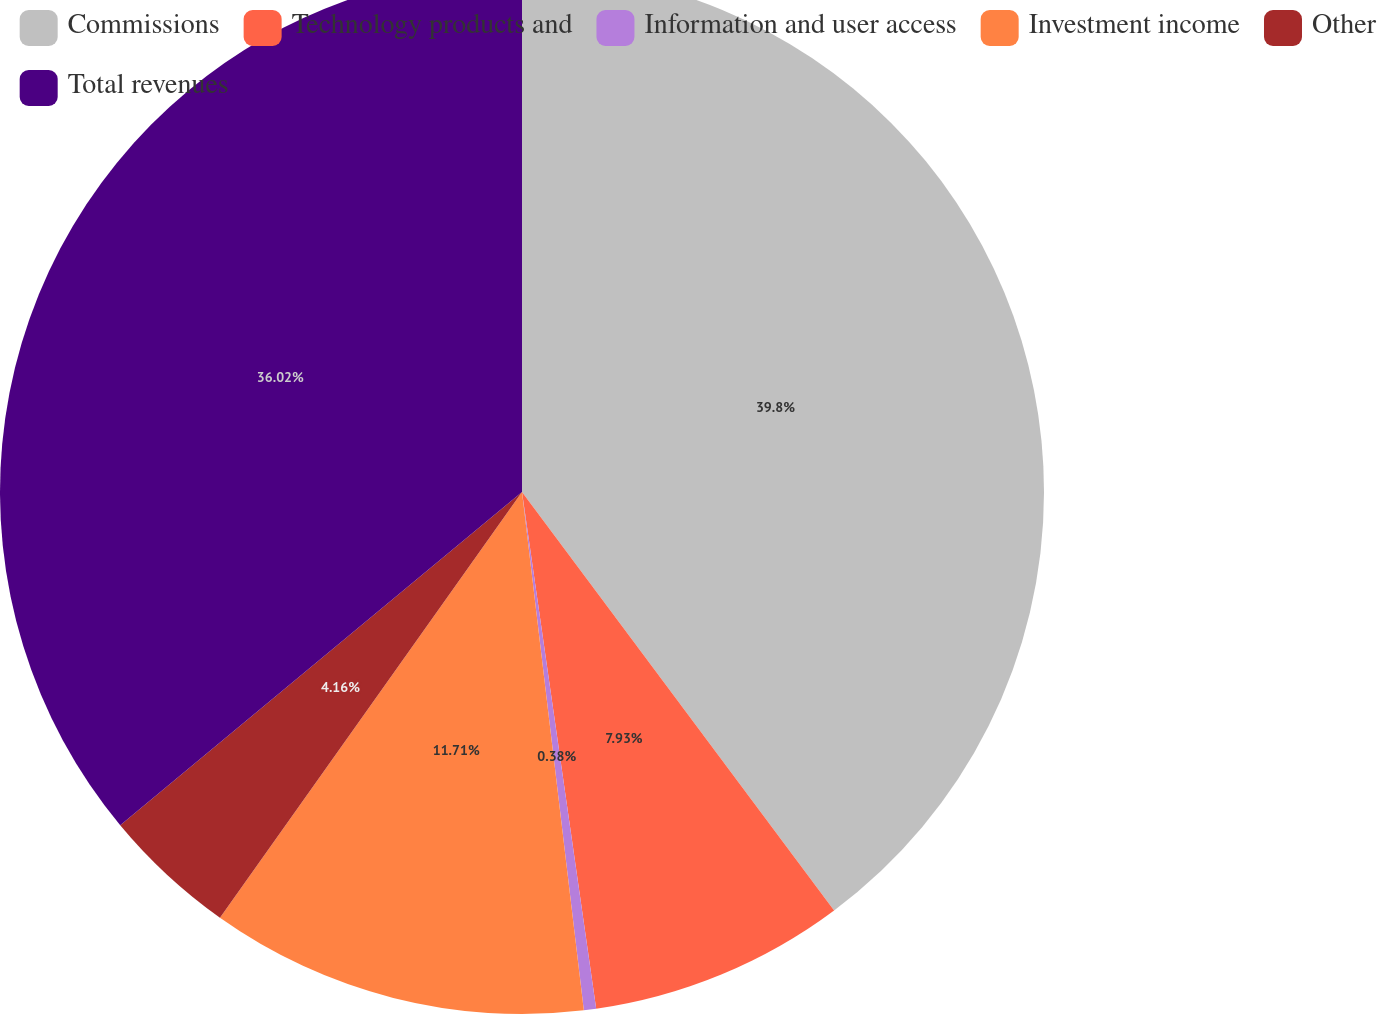<chart> <loc_0><loc_0><loc_500><loc_500><pie_chart><fcel>Commissions<fcel>Technology products and<fcel>Information and user access<fcel>Investment income<fcel>Other<fcel>Total revenues<nl><fcel>39.8%<fcel>7.93%<fcel>0.38%<fcel>11.71%<fcel>4.16%<fcel>36.02%<nl></chart> 